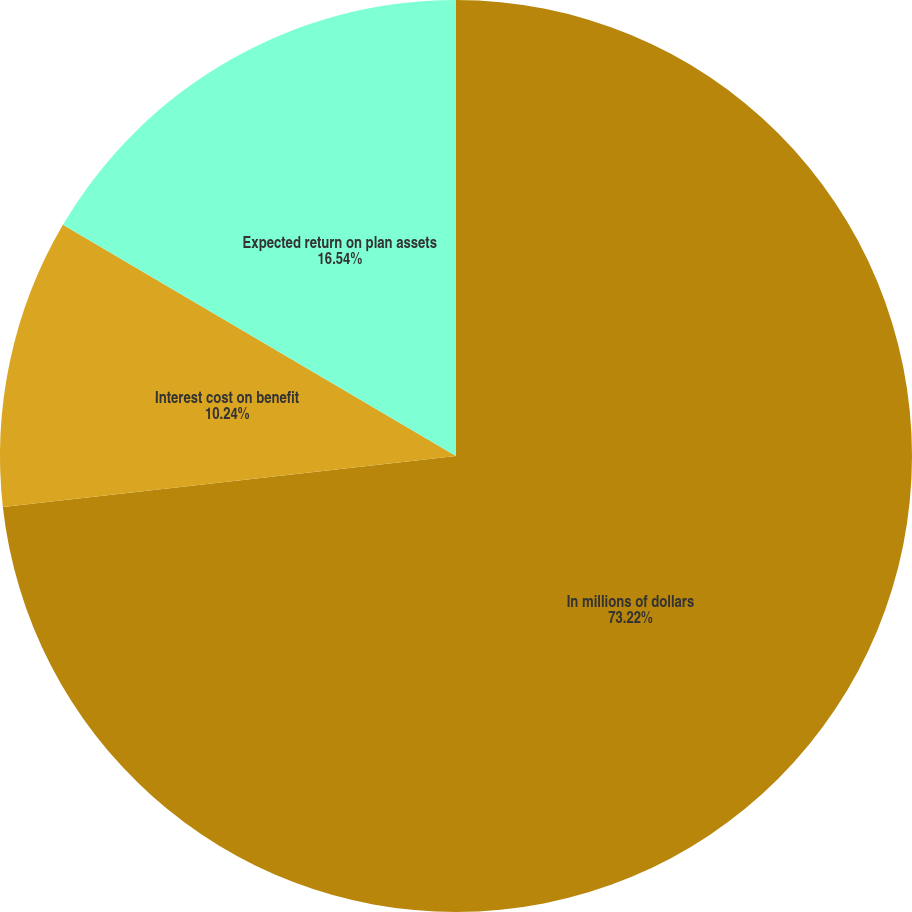Convert chart to OTSL. <chart><loc_0><loc_0><loc_500><loc_500><pie_chart><fcel>In millions of dollars<fcel>Interest cost on benefit<fcel>Expected return on plan assets<nl><fcel>73.22%<fcel>10.24%<fcel>16.54%<nl></chart> 